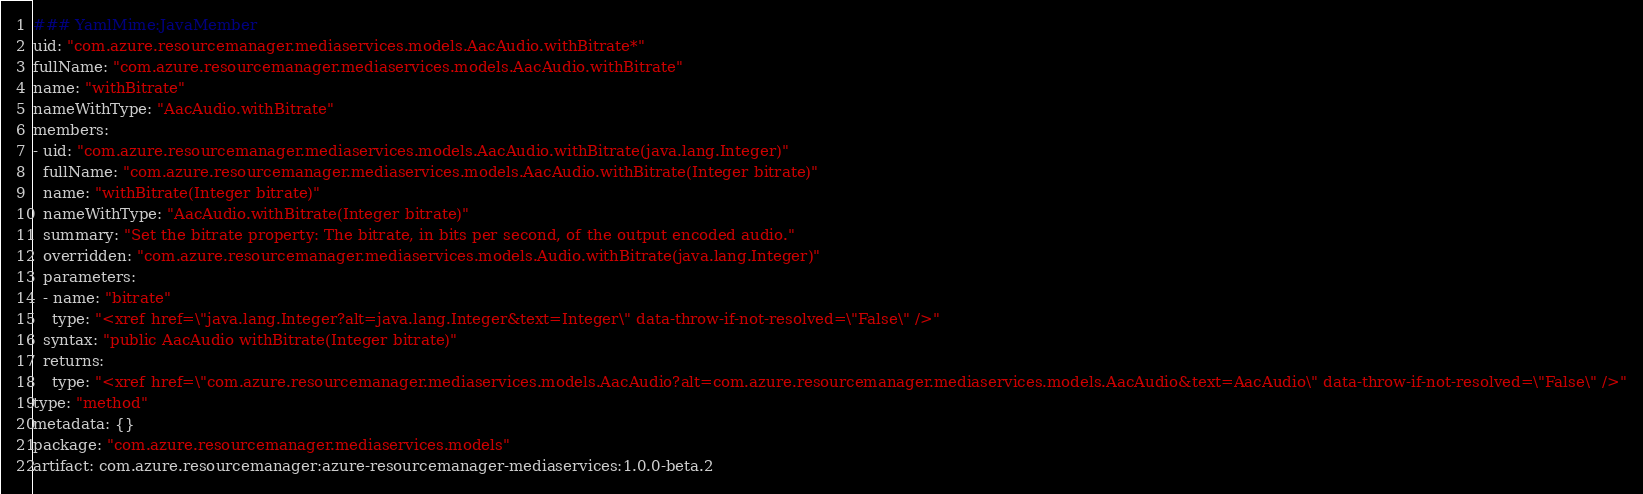<code> <loc_0><loc_0><loc_500><loc_500><_YAML_>### YamlMime:JavaMember
uid: "com.azure.resourcemanager.mediaservices.models.AacAudio.withBitrate*"
fullName: "com.azure.resourcemanager.mediaservices.models.AacAudio.withBitrate"
name: "withBitrate"
nameWithType: "AacAudio.withBitrate"
members:
- uid: "com.azure.resourcemanager.mediaservices.models.AacAudio.withBitrate(java.lang.Integer)"
  fullName: "com.azure.resourcemanager.mediaservices.models.AacAudio.withBitrate(Integer bitrate)"
  name: "withBitrate(Integer bitrate)"
  nameWithType: "AacAudio.withBitrate(Integer bitrate)"
  summary: "Set the bitrate property: The bitrate, in bits per second, of the output encoded audio."
  overridden: "com.azure.resourcemanager.mediaservices.models.Audio.withBitrate(java.lang.Integer)"
  parameters:
  - name: "bitrate"
    type: "<xref href=\"java.lang.Integer?alt=java.lang.Integer&text=Integer\" data-throw-if-not-resolved=\"False\" />"
  syntax: "public AacAudio withBitrate(Integer bitrate)"
  returns:
    type: "<xref href=\"com.azure.resourcemanager.mediaservices.models.AacAudio?alt=com.azure.resourcemanager.mediaservices.models.AacAudio&text=AacAudio\" data-throw-if-not-resolved=\"False\" />"
type: "method"
metadata: {}
package: "com.azure.resourcemanager.mediaservices.models"
artifact: com.azure.resourcemanager:azure-resourcemanager-mediaservices:1.0.0-beta.2
</code> 